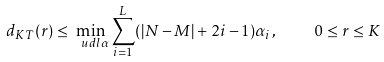<formula> <loc_0><loc_0><loc_500><loc_500>d _ { K T } ( r ) \leq \min _ { \ u d l { \alpha } } \sum _ { i = 1 } ^ { L } ( | N - M | + 2 i - 1 ) \alpha _ { i } , \quad 0 \leq r \leq K</formula> 